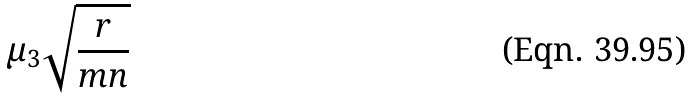Convert formula to latex. <formula><loc_0><loc_0><loc_500><loc_500>\mu _ { 3 } \sqrt { \frac { r } { m n } }</formula> 